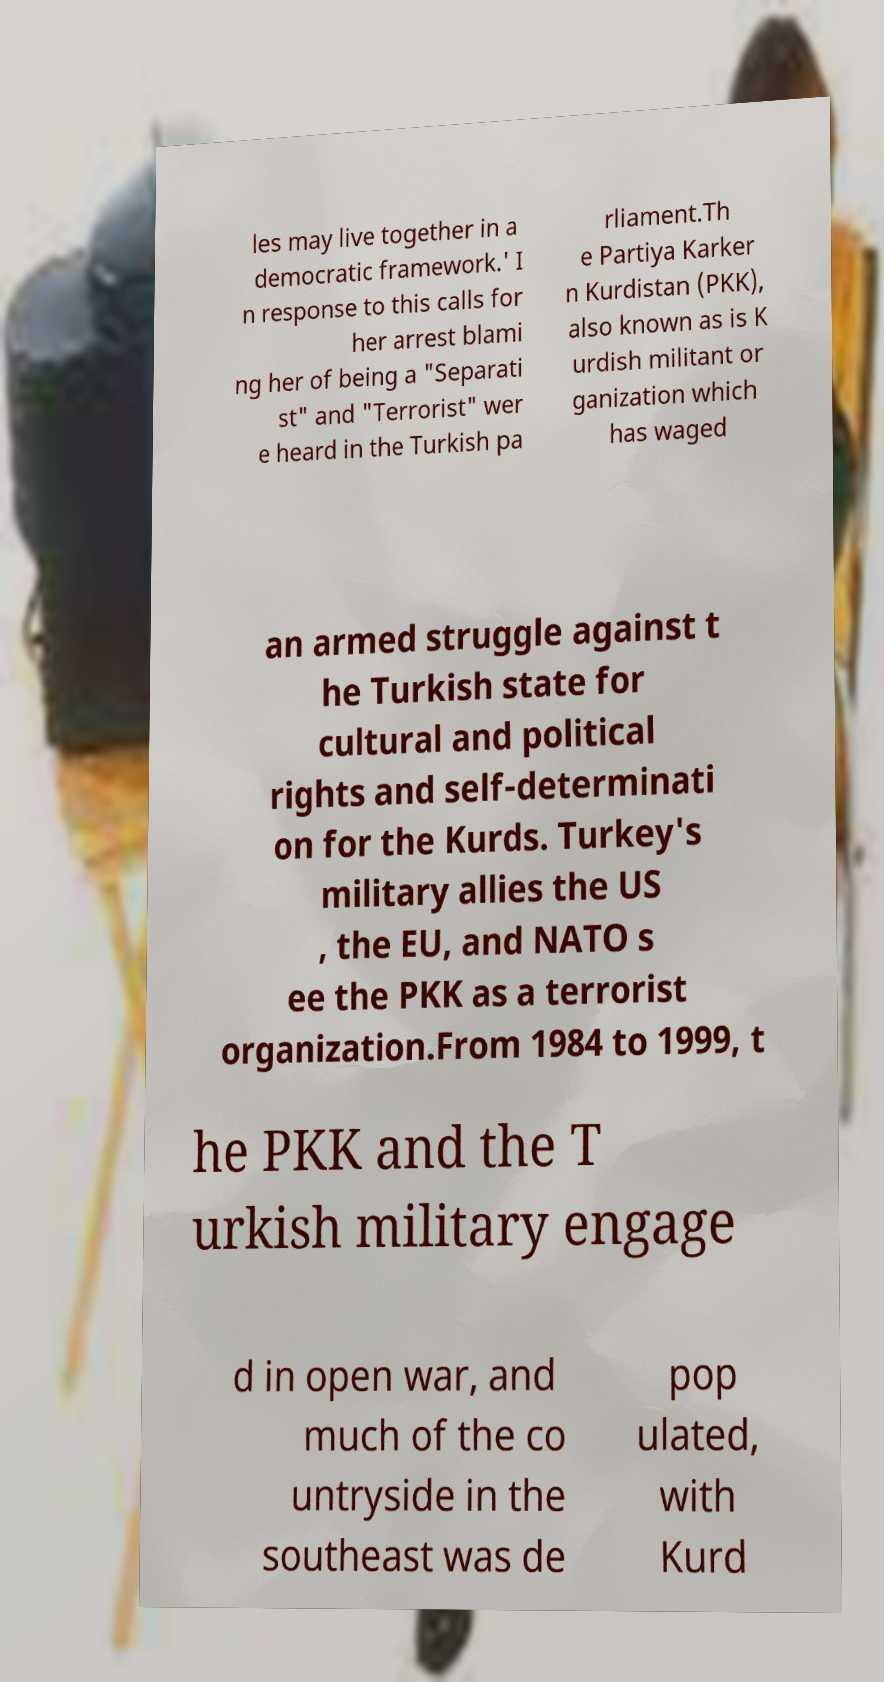Please read and relay the text visible in this image. What does it say? les may live together in a democratic framework.' I n response to this calls for her arrest blami ng her of being a "Separati st" and "Terrorist" wer e heard in the Turkish pa rliament.Th e Partiya Karker n Kurdistan (PKK), also known as is K urdish militant or ganization which has waged an armed struggle against t he Turkish state for cultural and political rights and self-determinati on for the Kurds. Turkey's military allies the US , the EU, and NATO s ee the PKK as a terrorist organization.From 1984 to 1999, t he PKK and the T urkish military engage d in open war, and much of the co untryside in the southeast was de pop ulated, with Kurd 